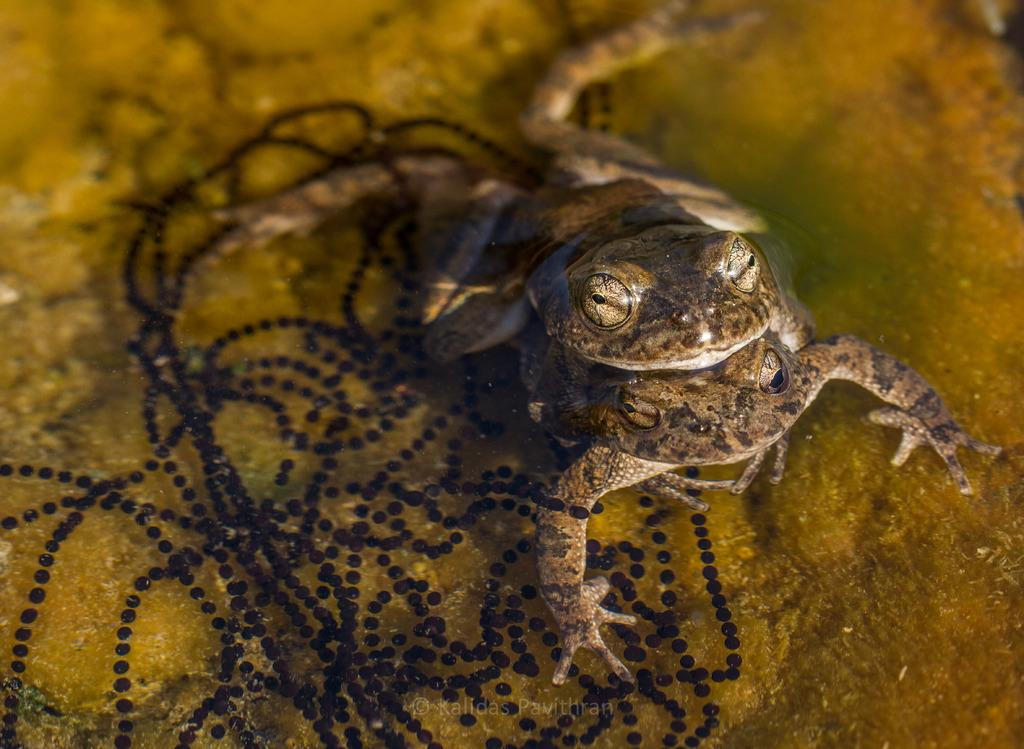What is the main subject in the center of the image? There is water in the center of the image. What animals can be seen in the water? There are two ducks in the water. What is the color of the ducks? The ducks are brown in color. What type of party is being held in the water? There is no party being held in the water; the image only shows two brown ducks in the water. 